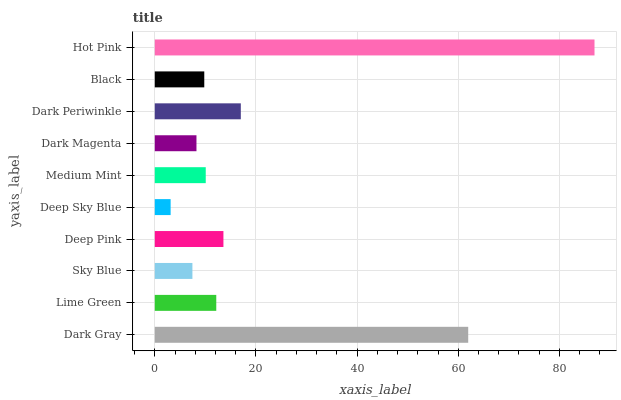Is Deep Sky Blue the minimum?
Answer yes or no. Yes. Is Hot Pink the maximum?
Answer yes or no. Yes. Is Lime Green the minimum?
Answer yes or no. No. Is Lime Green the maximum?
Answer yes or no. No. Is Dark Gray greater than Lime Green?
Answer yes or no. Yes. Is Lime Green less than Dark Gray?
Answer yes or no. Yes. Is Lime Green greater than Dark Gray?
Answer yes or no. No. Is Dark Gray less than Lime Green?
Answer yes or no. No. Is Lime Green the high median?
Answer yes or no. Yes. Is Medium Mint the low median?
Answer yes or no. Yes. Is Hot Pink the high median?
Answer yes or no. No. Is Deep Pink the low median?
Answer yes or no. No. 